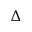Convert formula to latex. <formula><loc_0><loc_0><loc_500><loc_500>\Delta</formula> 